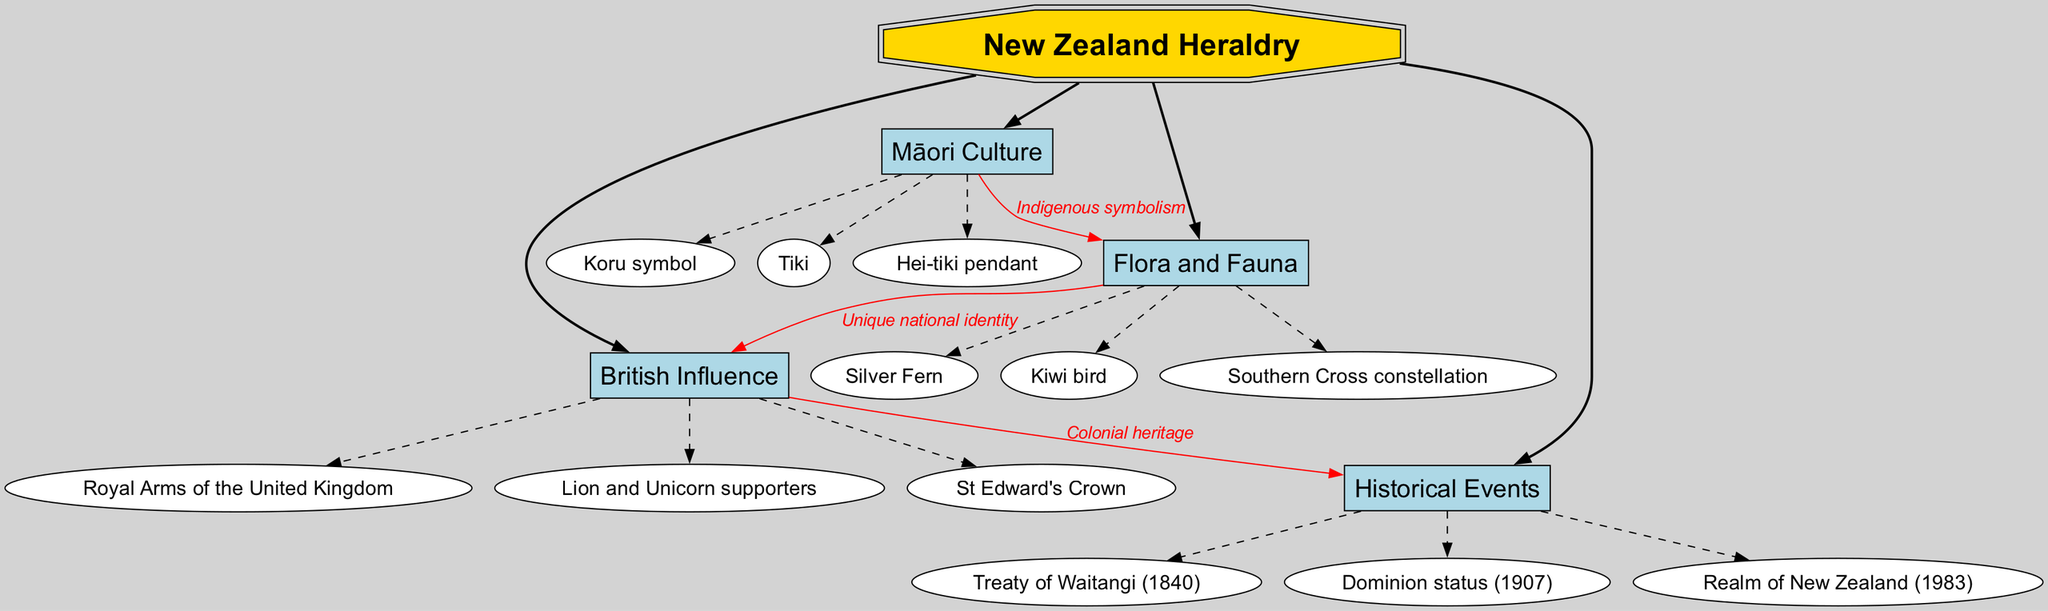What are the three main branches of the mind map? The mind map has four main branches: British Influence, Māori Culture, Flora and Fauna, and Historical Events.
Answer: British Influence, Māori Culture, Flora and Fauna What symbol is represented by the sub-branch "Tiki"? "Tiki" is a symbolic representation in Māori culture featured as a sub-branch within the Māori Culture branch.
Answer: Tiki How many sub-branches are under "Flora and Fauna"? There are three sub-branches listed under Flora and Fauna: Silver Fern, Kiwi bird, and Southern Cross constellation, making a total of three.
Answer: 3 Which historical event connects to "British Influence"? The connection labeled "Colonial heritage" indicates that "British Influence" is linked to "Historical Events," specifically suggesting a historical context for colonization, resulting in the Treaty of Waitangi (1840), which connects both branches.
Answer: Treaty of Waitangi (1840) What is the color of the node representing "Māori Culture"? The node representing "Māori Culture" is styled with a light blue fill color, which is consistent across the main branches of the diagram.
Answer: Light blue What are the two cultures referenced in the connections of the mind map? The connections show the influence of British culture and Māori culture on specific aspects of New Zealand heraldry, with cultural context tied through various events and symbols in the diagram.
Answer: British culture and Māori culture Which symbol under "Flora and Fauna" is associated with a unique national identity? The diagram indicates that "Silver Fern" and "Kiwi bird" are tied to the notion of a unique national identity as part of the Flora and Fauna branch.
Answer: Silver Fern What does the connection labeled "Indigenous symbolism" link? The "Indigenous symbolism" connection links "Māori Culture" to "Flora and Fauna," indicating how Māori culture influences and reflects on the natural symbols representative of New Zealand.
Answer: Māori Culture to Flora and Fauna Which symbol under "Māori Culture" has a specific representation as a pendant? The "Hei-tiki pendant" in the sub-branch of Māori Culture specifically represents a symbolic form that is culturally significant in Māori traditions.
Answer: Hei-tiki pendant 